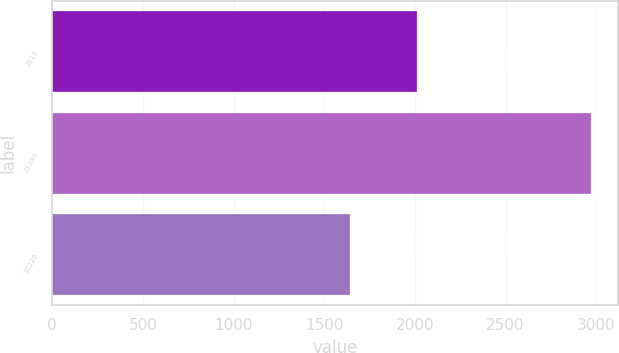<chart> <loc_0><loc_0><loc_500><loc_500><bar_chart><fcel>2013<fcel>21380<fcel>10226<nl><fcel>2013<fcel>2972.5<fcel>1644.5<nl></chart> 